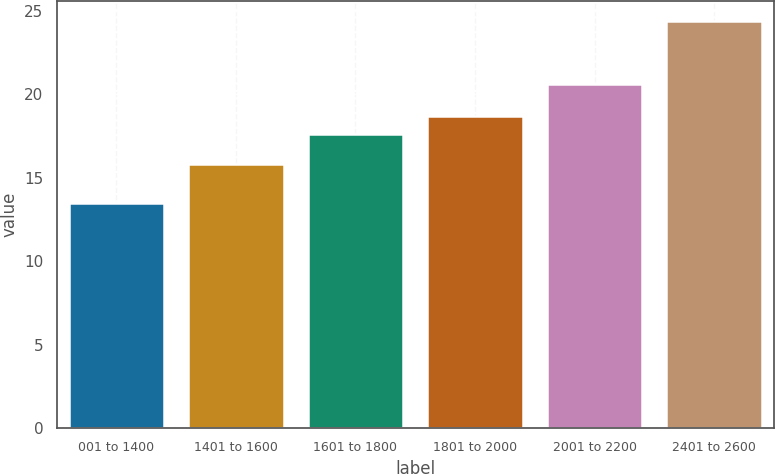Convert chart. <chart><loc_0><loc_0><loc_500><loc_500><bar_chart><fcel>001 to 1400<fcel>1401 to 1600<fcel>1601 to 1800<fcel>1801 to 2000<fcel>2001 to 2200<fcel>2401 to 2600<nl><fcel>13.5<fcel>15.85<fcel>17.6<fcel>18.69<fcel>20.63<fcel>24.39<nl></chart> 